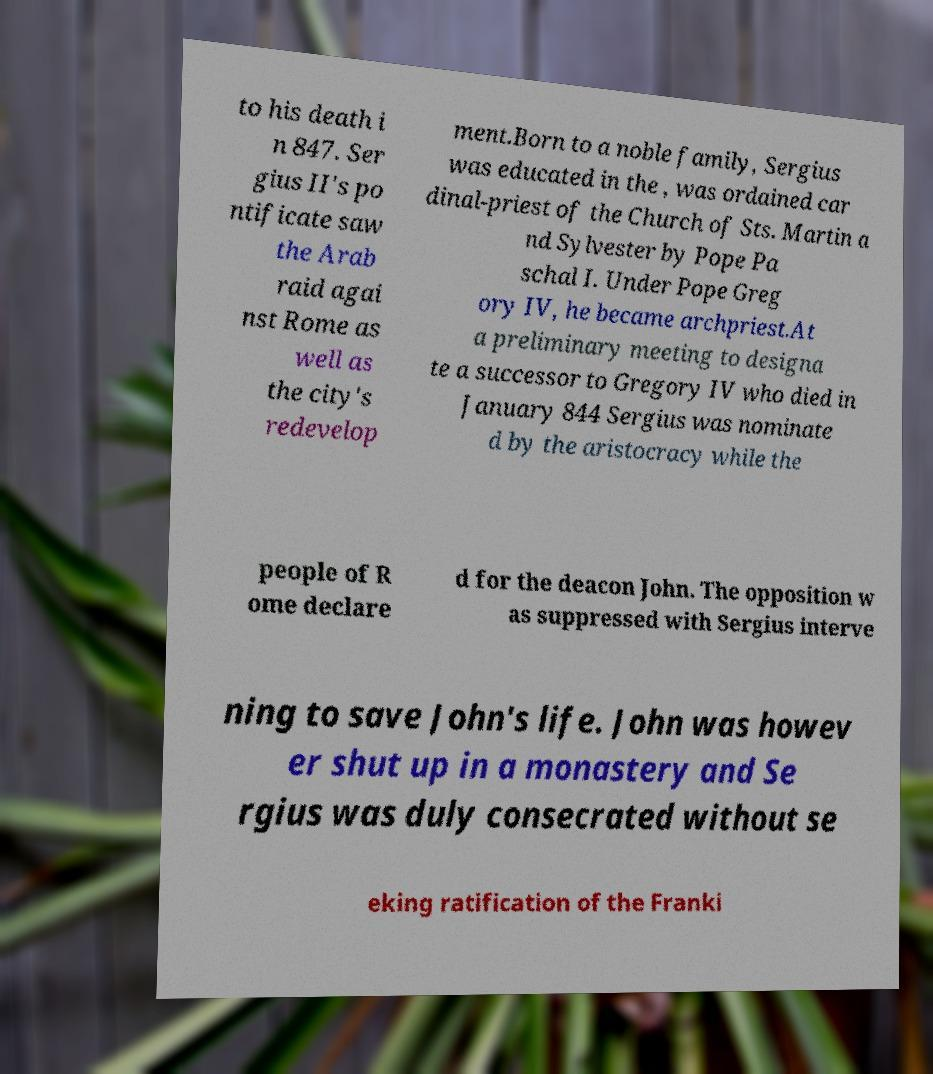For documentation purposes, I need the text within this image transcribed. Could you provide that? to his death i n 847. Ser gius II's po ntificate saw the Arab raid agai nst Rome as well as the city's redevelop ment.Born to a noble family, Sergius was educated in the , was ordained car dinal-priest of the Church of Sts. Martin a nd Sylvester by Pope Pa schal I. Under Pope Greg ory IV, he became archpriest.At a preliminary meeting to designa te a successor to Gregory IV who died in January 844 Sergius was nominate d by the aristocracy while the people of R ome declare d for the deacon John. The opposition w as suppressed with Sergius interve ning to save John's life. John was howev er shut up in a monastery and Se rgius was duly consecrated without se eking ratification of the Franki 